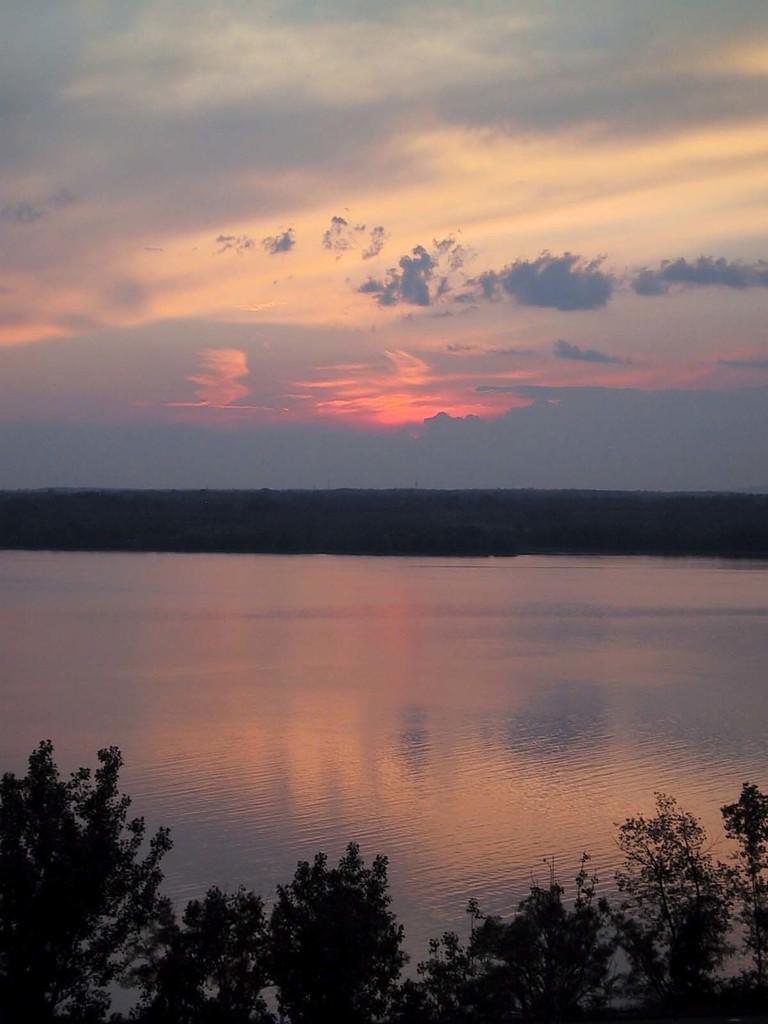How would you summarize this image in a sentence or two? At the bottom of the image there are trees. Behind the trees there is water. At the top of the image there is a sky with clouds. 